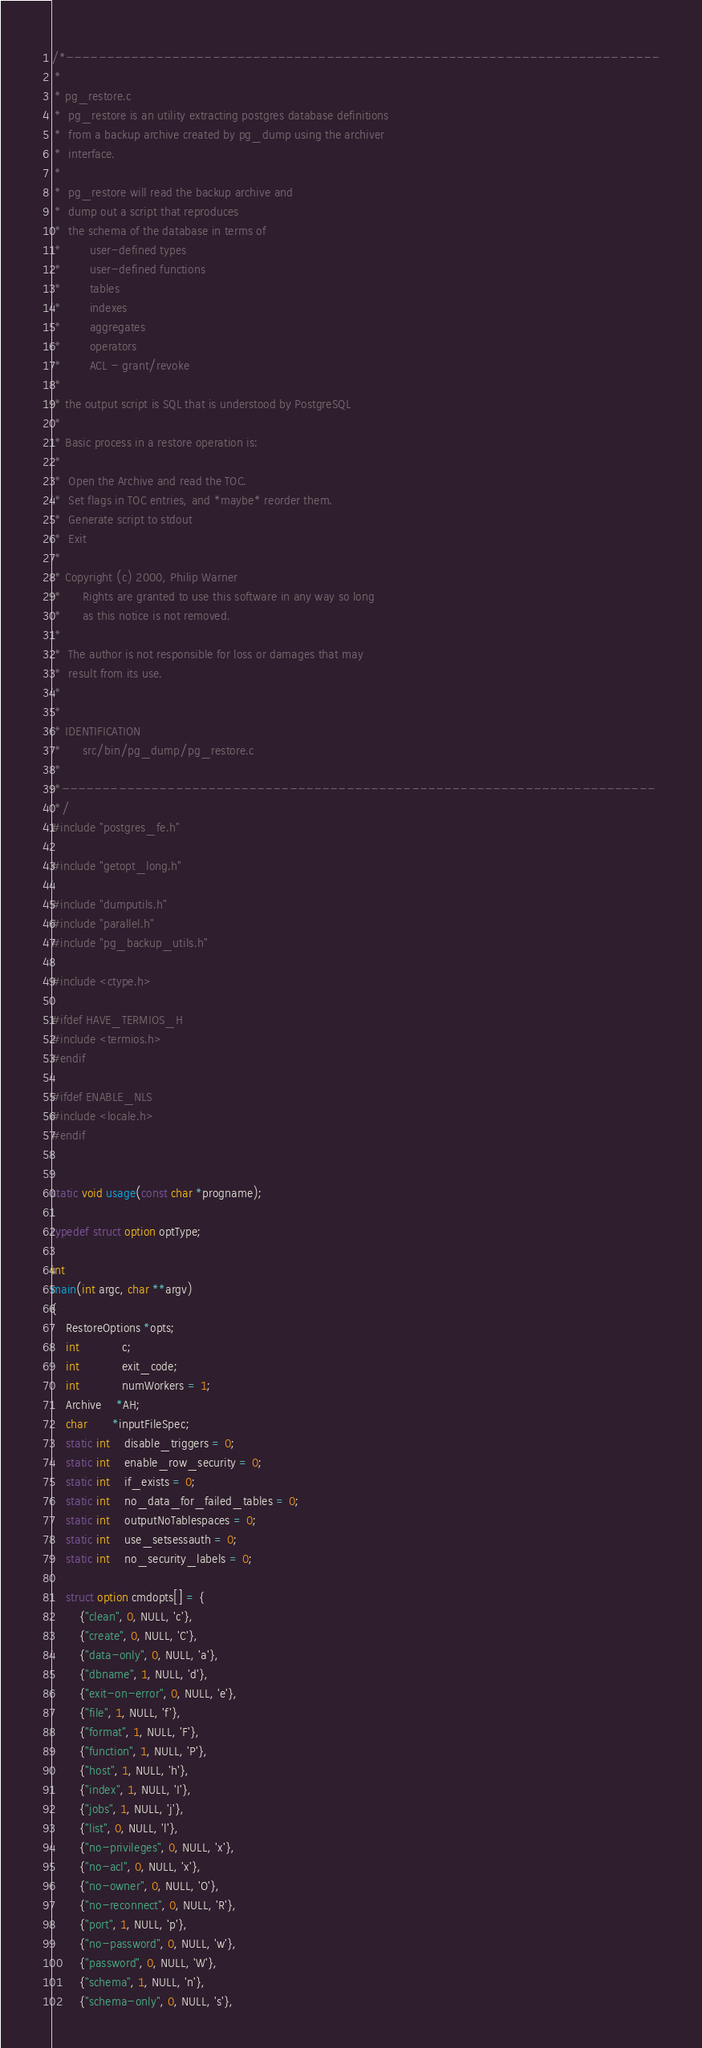Convert code to text. <code><loc_0><loc_0><loc_500><loc_500><_C_>/*-------------------------------------------------------------------------
 *
 * pg_restore.c
 *	pg_restore is an utility extracting postgres database definitions
 *	from a backup archive created by pg_dump using the archiver
 *	interface.
 *
 *	pg_restore will read the backup archive and
 *	dump out a script that reproduces
 *	the schema of the database in terms of
 *		  user-defined types
 *		  user-defined functions
 *		  tables
 *		  indexes
 *		  aggregates
 *		  operators
 *		  ACL - grant/revoke
 *
 * the output script is SQL that is understood by PostgreSQL
 *
 * Basic process in a restore operation is:
 *
 *	Open the Archive and read the TOC.
 *	Set flags in TOC entries, and *maybe* reorder them.
 *	Generate script to stdout
 *	Exit
 *
 * Copyright (c) 2000, Philip Warner
 *		Rights are granted to use this software in any way so long
 *		as this notice is not removed.
 *
 *	The author is not responsible for loss or damages that may
 *	result from its use.
 *
 *
 * IDENTIFICATION
 *		src/bin/pg_dump/pg_restore.c
 *
 *-------------------------------------------------------------------------
 */
#include "postgres_fe.h"

#include "getopt_long.h"

#include "dumputils.h"
#include "parallel.h"
#include "pg_backup_utils.h"

#include <ctype.h>

#ifdef HAVE_TERMIOS_H
#include <termios.h>
#endif

#ifdef ENABLE_NLS
#include <locale.h>
#endif


static void usage(const char *progname);

typedef struct option optType;

int
main(int argc, char **argv)
{
	RestoreOptions *opts;
	int			c;
	int			exit_code;
	int			numWorkers = 1;
	Archive    *AH;
	char	   *inputFileSpec;
	static int	disable_triggers = 0;
	static int	enable_row_security = 0;
	static int	if_exists = 0;
	static int	no_data_for_failed_tables = 0;
	static int	outputNoTablespaces = 0;
	static int	use_setsessauth = 0;
	static int	no_security_labels = 0;

	struct option cmdopts[] = {
		{"clean", 0, NULL, 'c'},
		{"create", 0, NULL, 'C'},
		{"data-only", 0, NULL, 'a'},
		{"dbname", 1, NULL, 'd'},
		{"exit-on-error", 0, NULL, 'e'},
		{"file", 1, NULL, 'f'},
		{"format", 1, NULL, 'F'},
		{"function", 1, NULL, 'P'},
		{"host", 1, NULL, 'h'},
		{"index", 1, NULL, 'I'},
		{"jobs", 1, NULL, 'j'},
		{"list", 0, NULL, 'l'},
		{"no-privileges", 0, NULL, 'x'},
		{"no-acl", 0, NULL, 'x'},
		{"no-owner", 0, NULL, 'O'},
		{"no-reconnect", 0, NULL, 'R'},
		{"port", 1, NULL, 'p'},
		{"no-password", 0, NULL, 'w'},
		{"password", 0, NULL, 'W'},
		{"schema", 1, NULL, 'n'},
		{"schema-only", 0, NULL, 's'},</code> 